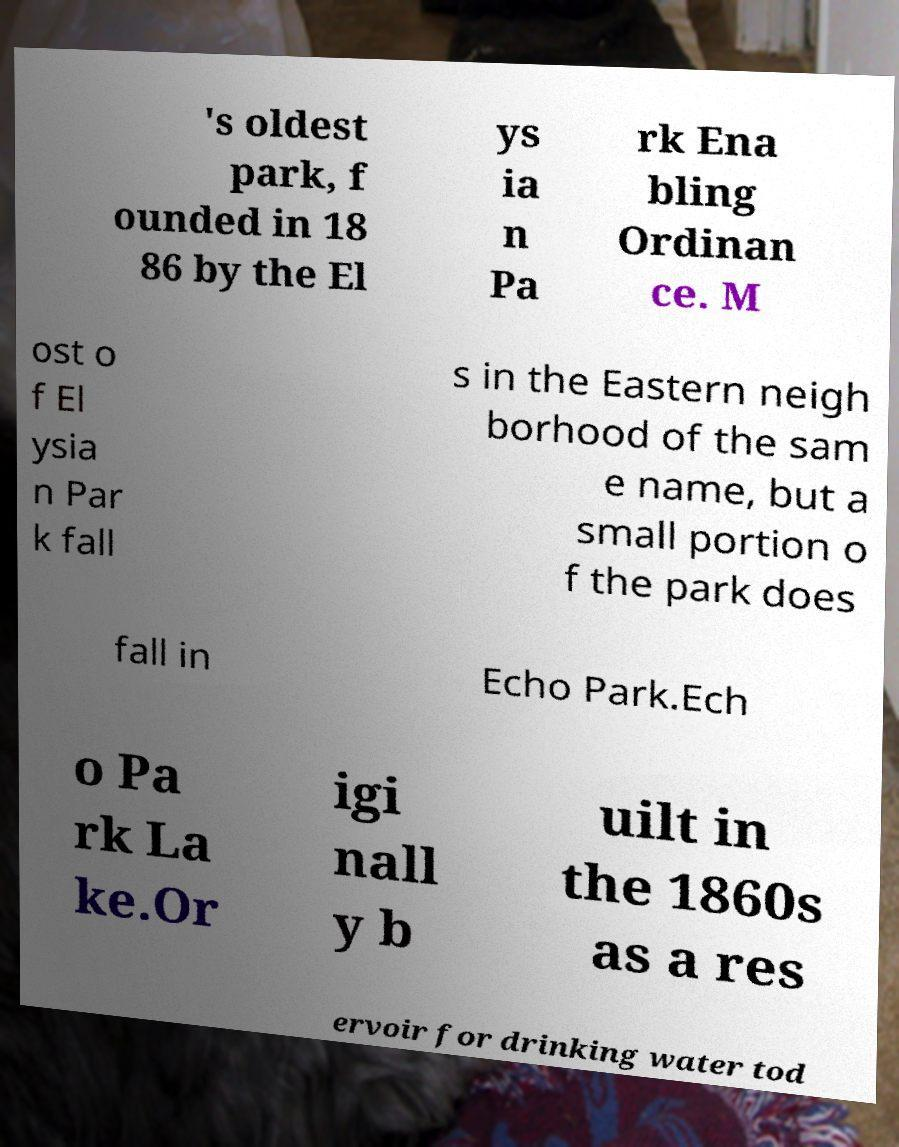There's text embedded in this image that I need extracted. Can you transcribe it verbatim? 's oldest park, f ounded in 18 86 by the El ys ia n Pa rk Ena bling Ordinan ce. M ost o f El ysia n Par k fall s in the Eastern neigh borhood of the sam e name, but a small portion o f the park does fall in Echo Park.Ech o Pa rk La ke.Or igi nall y b uilt in the 1860s as a res ervoir for drinking water tod 